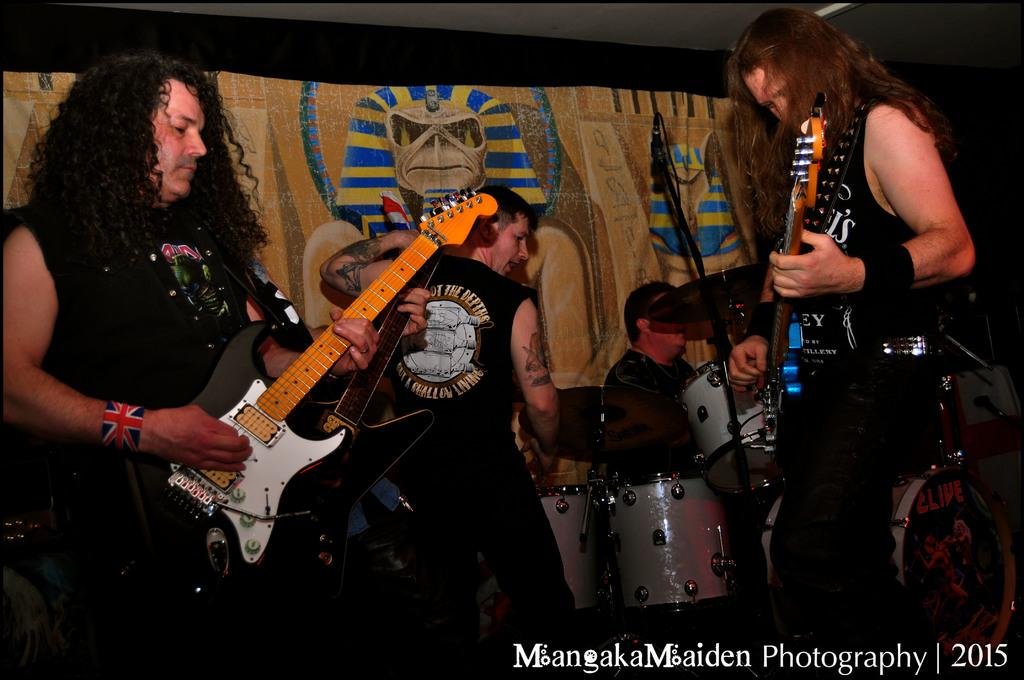What is happening in the image involving the people? The people in the image are performing. What are the people doing while performing? The people are playing musical instruments. Is there any additional information about the performance? Yes, there is a banner visible in the image. What type of polish is being applied to the musical instruments in the image? There is no indication in the image that any polish is being applied to the musical instruments. Can you tell me how many clocks are visible in the image? There is no mention of clocks in the image; the focus is on the people performing and playing musical instruments. 